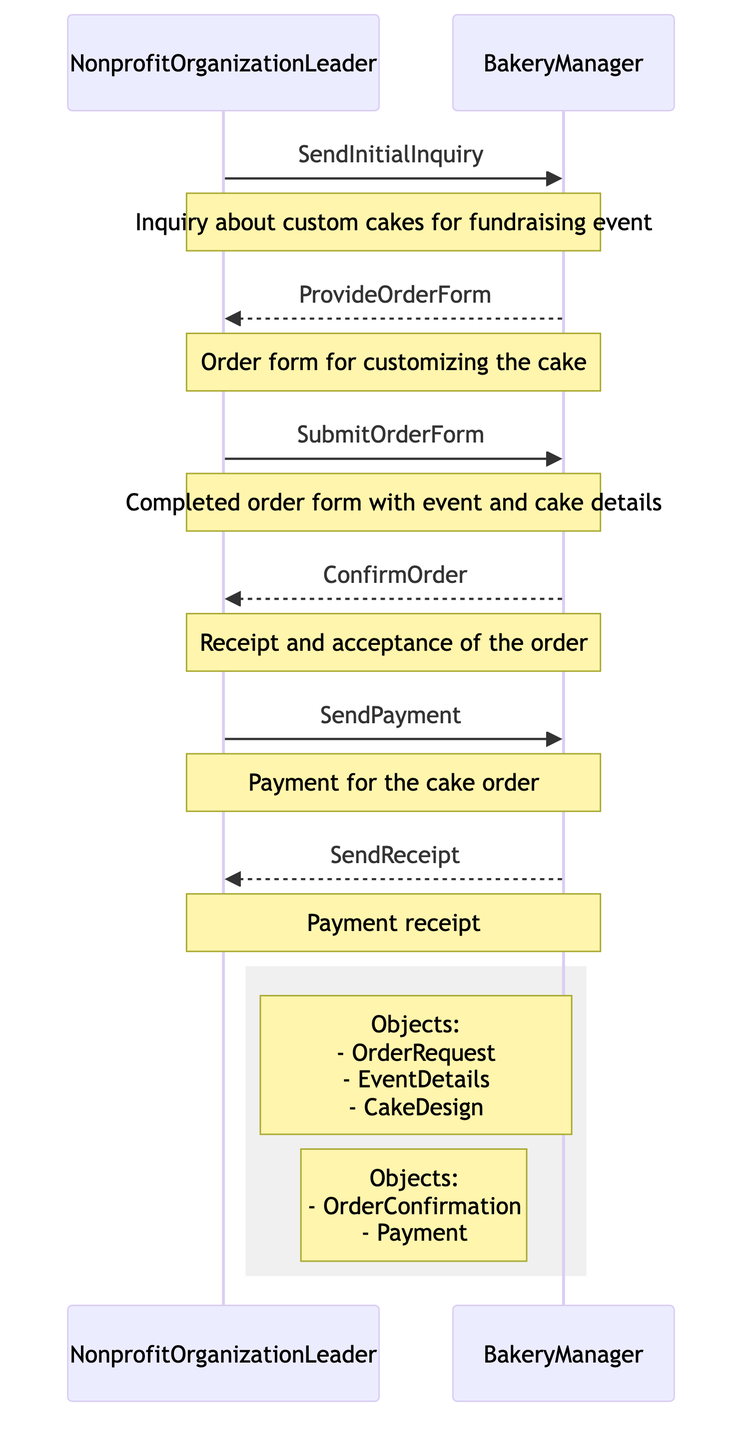What is the first action taken by the Nonprofit Organization Leader? The first action depicted in the diagram is the 'SendInitialInquiry' from the Nonprofit Organization Leader to the Bakery Manager, indicating that the leader is inquiring about custom cakes.
Answer: SendInitialInquiry How many objects are listed for the Bakery Manager? In the right-hand side note, it shows that there are two objects listed for the Bakery Manager: 'OrderConfirmation' and 'Payment'.
Answer: 2 What message does the Bakery Manager send back after providing the order form? The Bakery Manager sends the message 'ConfirmOrder' back to the Nonprofit Organization Leader, confirming the acceptance and receipt of the submitted order.
Answer: ConfirmOrder What is sent after the Nonprofit Organization Leader submits the order form? After the Nonprofit Organization Leader submits the order form, the Bakery Manager sends back the 'ConfirmOrder', indicating that the order has been acknowledged.
Answer: ConfirmOrder What payment-related message does the Nonprofit Organization Leader send? The Nonprofit Organization Leader sends the message 'SendPayment', which indicates the action of sending payment for the cake order to the Bakery Manager.
Answer: SendPayment Which entity initiates the inquiry about custom cakes? The inquiry is initiated by the Nonprofit Organization Leader as indicated by the first action in the sequence where they send an inquiry to the Bakery Manager.
Answer: NonprofitOrganizationLeader What types of objects does the Nonprofit Organization Leader deal with? The Nonprofit Organization Leader is associated with three objects: 'OrderRequest', 'EventDetails', and 'CakeDesign', which are listed in the diagram.
Answer: OrderRequest, EventDetails, CakeDesign What confirmation is sent at the end of the payment process? At the end of the payment process, the Bakery Manager sends 'SendReceipt', which serves as confirmation of payment receipt for the order placed by the Nonprofit Organization Leader.
Answer: SendReceipt What role does the Bakery Manager play in this process? The Bakery Manager's role includes receiving inquiries, providing order forms, confirming orders, and sending payment receipts for cake orders.
Answer: BakeryManager 